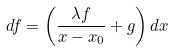Convert formula to latex. <formula><loc_0><loc_0><loc_500><loc_500>d f = \left ( \frac { \lambda f } { x - x _ { 0 } } + g \right ) d x</formula> 